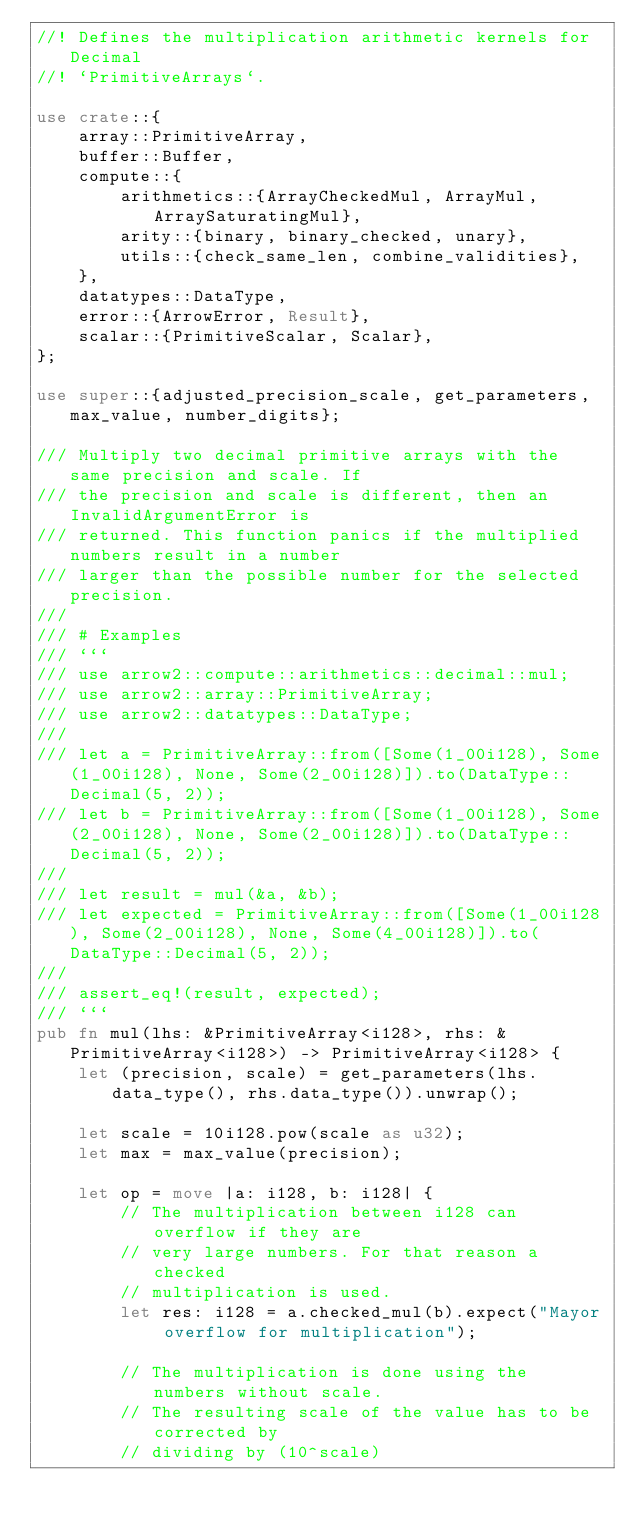Convert code to text. <code><loc_0><loc_0><loc_500><loc_500><_Rust_>//! Defines the multiplication arithmetic kernels for Decimal
//! `PrimitiveArrays`.

use crate::{
    array::PrimitiveArray,
    buffer::Buffer,
    compute::{
        arithmetics::{ArrayCheckedMul, ArrayMul, ArraySaturatingMul},
        arity::{binary, binary_checked, unary},
        utils::{check_same_len, combine_validities},
    },
    datatypes::DataType,
    error::{ArrowError, Result},
    scalar::{PrimitiveScalar, Scalar},
};

use super::{adjusted_precision_scale, get_parameters, max_value, number_digits};

/// Multiply two decimal primitive arrays with the same precision and scale. If
/// the precision and scale is different, then an InvalidArgumentError is
/// returned. This function panics if the multiplied numbers result in a number
/// larger than the possible number for the selected precision.
///
/// # Examples
/// ```
/// use arrow2::compute::arithmetics::decimal::mul;
/// use arrow2::array::PrimitiveArray;
/// use arrow2::datatypes::DataType;
///
/// let a = PrimitiveArray::from([Some(1_00i128), Some(1_00i128), None, Some(2_00i128)]).to(DataType::Decimal(5, 2));
/// let b = PrimitiveArray::from([Some(1_00i128), Some(2_00i128), None, Some(2_00i128)]).to(DataType::Decimal(5, 2));
///
/// let result = mul(&a, &b);
/// let expected = PrimitiveArray::from([Some(1_00i128), Some(2_00i128), None, Some(4_00i128)]).to(DataType::Decimal(5, 2));
///
/// assert_eq!(result, expected);
/// ```
pub fn mul(lhs: &PrimitiveArray<i128>, rhs: &PrimitiveArray<i128>) -> PrimitiveArray<i128> {
    let (precision, scale) = get_parameters(lhs.data_type(), rhs.data_type()).unwrap();

    let scale = 10i128.pow(scale as u32);
    let max = max_value(precision);

    let op = move |a: i128, b: i128| {
        // The multiplication between i128 can overflow if they are
        // very large numbers. For that reason a checked
        // multiplication is used.
        let res: i128 = a.checked_mul(b).expect("Mayor overflow for multiplication");

        // The multiplication is done using the numbers without scale.
        // The resulting scale of the value has to be corrected by
        // dividing by (10^scale)
</code> 